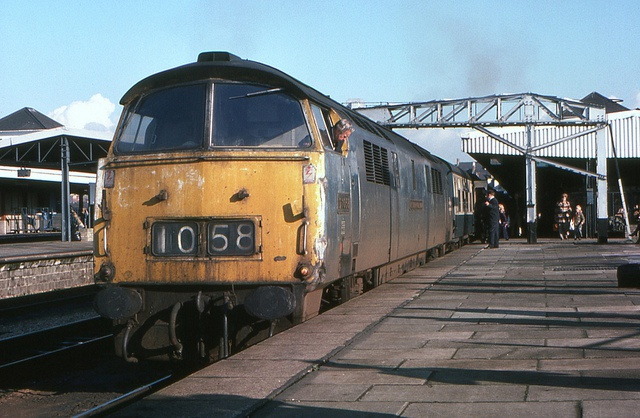Describe the objects in this image and their specific colors. I can see train in lightblue, black, gray, and tan tones, people in lightblue, black, gray, and darkblue tones, people in lightblue, gray, black, and maroon tones, people in lightblue, black, gray, maroon, and brown tones, and people in lightblue, black, gray, and maroon tones in this image. 